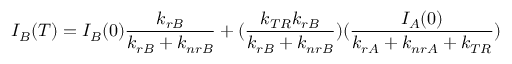<formula> <loc_0><loc_0><loc_500><loc_500>I _ { B } ( T ) = I _ { B } ( 0 ) \frac { k _ { r B } } { k _ { r B } + k _ { n r B } } + ( \frac { k _ { T R } k _ { r B } } { k _ { r B } + k _ { n r B } } ) ( \frac { I _ { A } ( 0 ) } { k _ { r A } + k _ { n r A } + k _ { T R } } )</formula> 